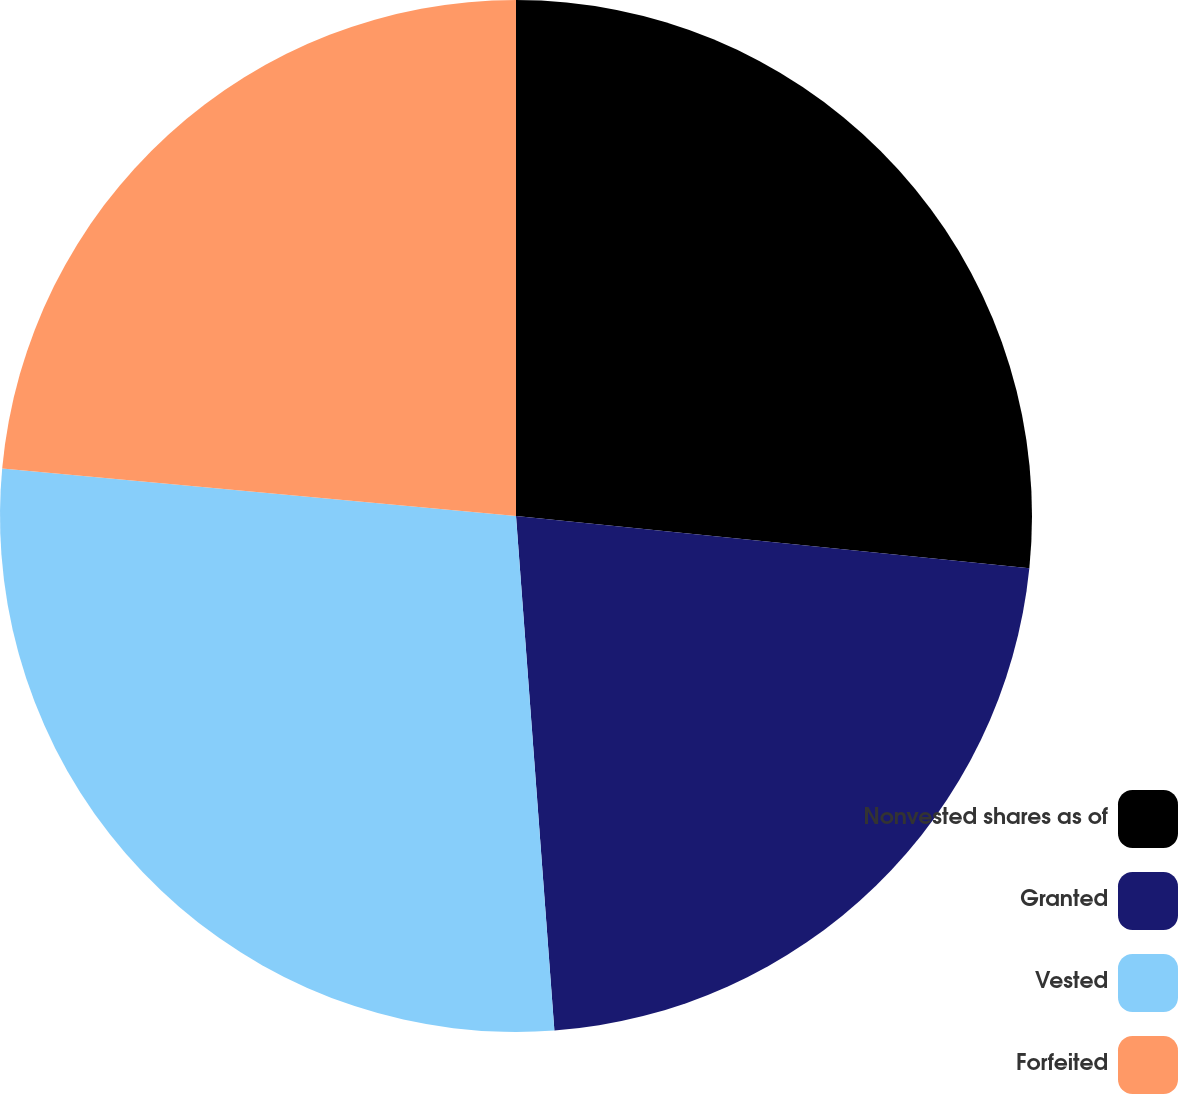<chart> <loc_0><loc_0><loc_500><loc_500><pie_chart><fcel>Nonvested shares as of<fcel>Granted<fcel>Vested<fcel>Forfeited<nl><fcel>26.61%<fcel>22.2%<fcel>27.65%<fcel>23.53%<nl></chart> 